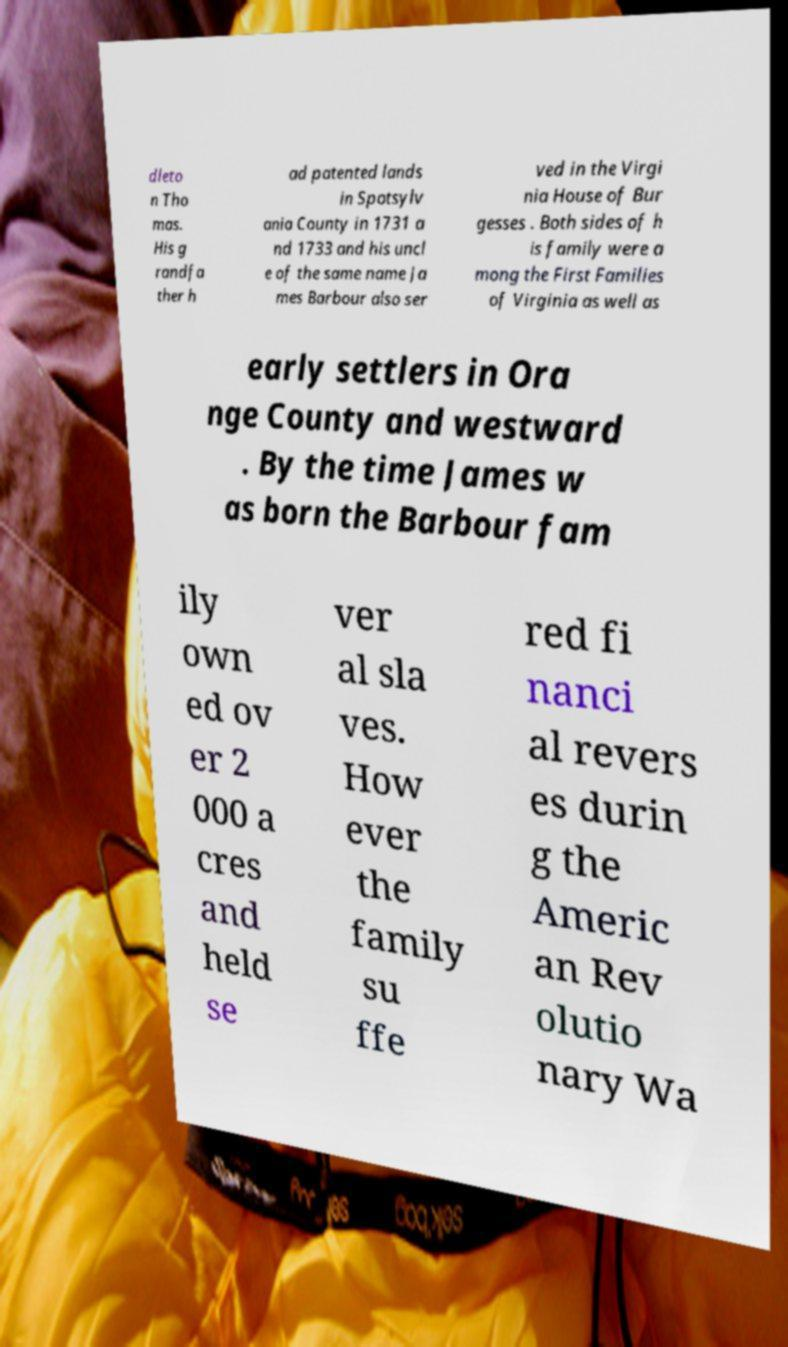Can you read and provide the text displayed in the image?This photo seems to have some interesting text. Can you extract and type it out for me? dleto n Tho mas. His g randfa ther h ad patented lands in Spotsylv ania County in 1731 a nd 1733 and his uncl e of the same name Ja mes Barbour also ser ved in the Virgi nia House of Bur gesses . Both sides of h is family were a mong the First Families of Virginia as well as early settlers in Ora nge County and westward . By the time James w as born the Barbour fam ily own ed ov er 2 000 a cres and held se ver al sla ves. How ever the family su ffe red fi nanci al revers es durin g the Americ an Rev olutio nary Wa 